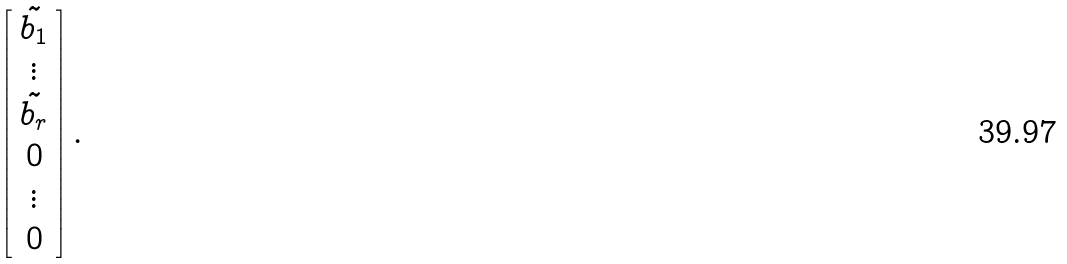Convert formula to latex. <formula><loc_0><loc_0><loc_500><loc_500>\left [ \begin{array} { c } \tilde { b _ { 1 } } \\ \vdots \\ \tilde { b _ { r } } \\ 0 \\ \vdots \\ 0 \end{array} \right ] .</formula> 